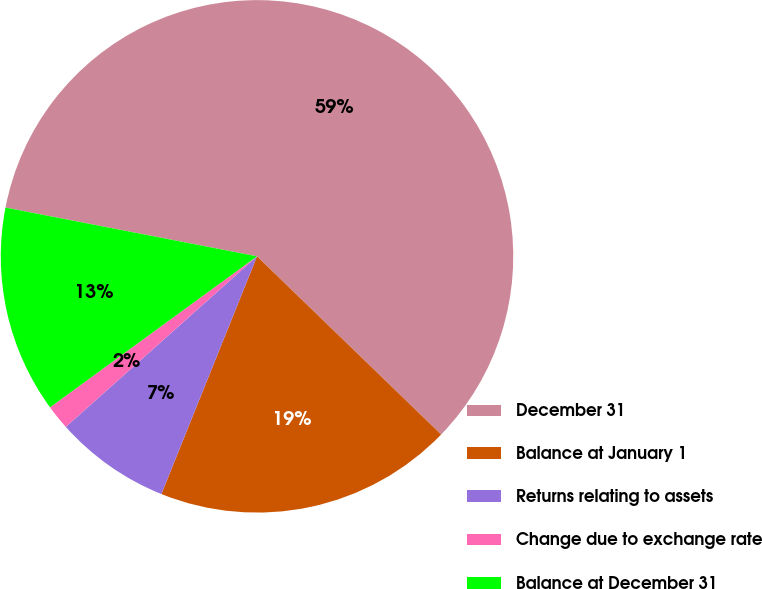Convert chart. <chart><loc_0><loc_0><loc_500><loc_500><pie_chart><fcel>December 31<fcel>Balance at January 1<fcel>Returns relating to assets<fcel>Change due to exchange rate<fcel>Balance at December 31<nl><fcel>59.19%<fcel>18.85%<fcel>7.32%<fcel>1.56%<fcel>13.08%<nl></chart> 